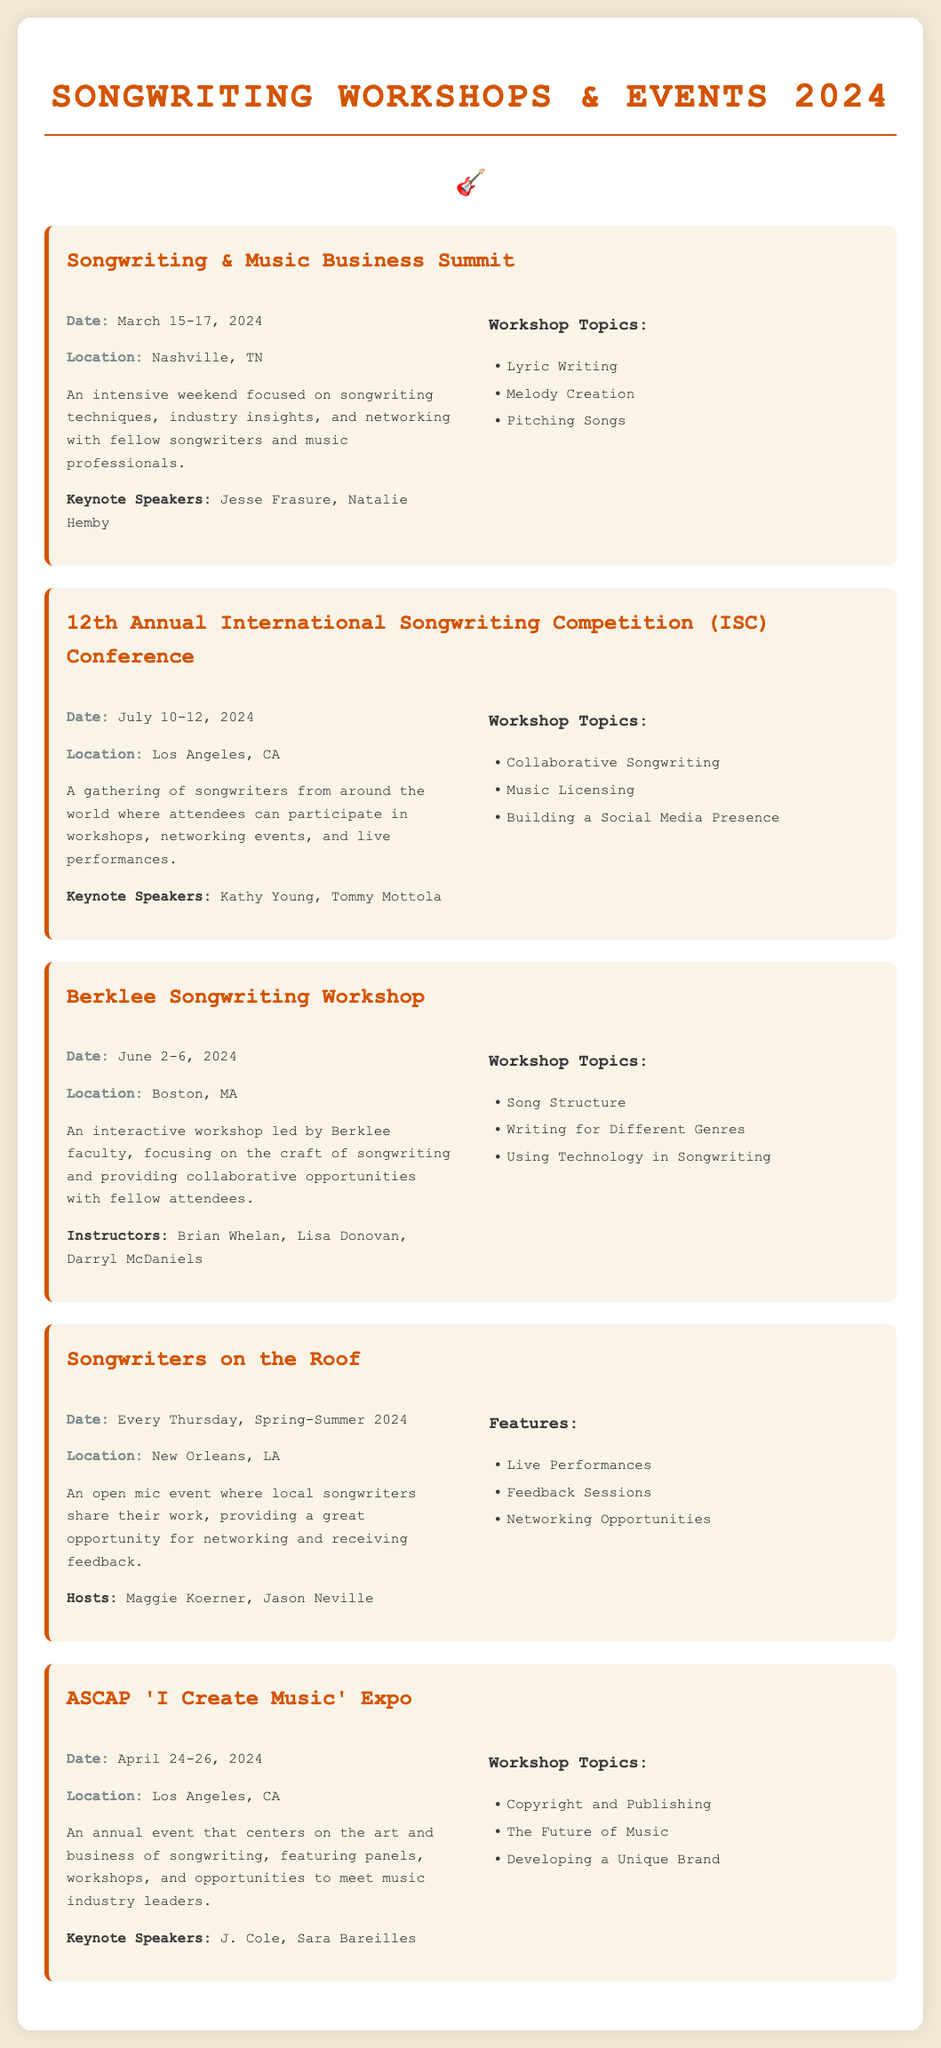what is the date of the Songwriting & Music Business Summit? The date is specifically stated in the event details section as March 15-17, 2024.
Answer: March 15-17, 2024 where is the Berklee Songwriting Workshop held? The location of the Berklee Songwriting Workshop is mentioned as Boston, MA.
Answer: Boston, MA who are the keynote speakers for the ASCAP 'I Create Music' Expo? The keynote speakers are listed under the event details, which include J. Cole and Sara Bareilles.
Answer: J. Cole, Sara Bareilles what is one of the workshop topics discussed at the 12th Annual International Songwriting Competition Conference? The document lists multiple topics, one being Collaborative Songwriting, which is a key area of focus for this event.
Answer: Collaborative Songwriting how often does the Songwriters on the Roof event occur? The frequency is detailed in the event description as every Thursday during the Spring-Summer 2024 period.
Answer: Every Thursday who are the hosts of the Songwriters on the Roof event? The hosts are identified within the event details as Maggie Koerner and Jason Neville.
Answer: Maggie Koerner, Jason Neville what is a key focus of the Berklee Songwriting Workshop? The document highlights the craft of songwriting as the main focus of this interactive workshop led by Berklee faculty.
Answer: The craft of songwriting which city hosts the ASCAP 'I Create Music' Expo? The event's location is found in the event details, which specify that it is held in Los Angeles, CA.
Answer: Los Angeles, CA 